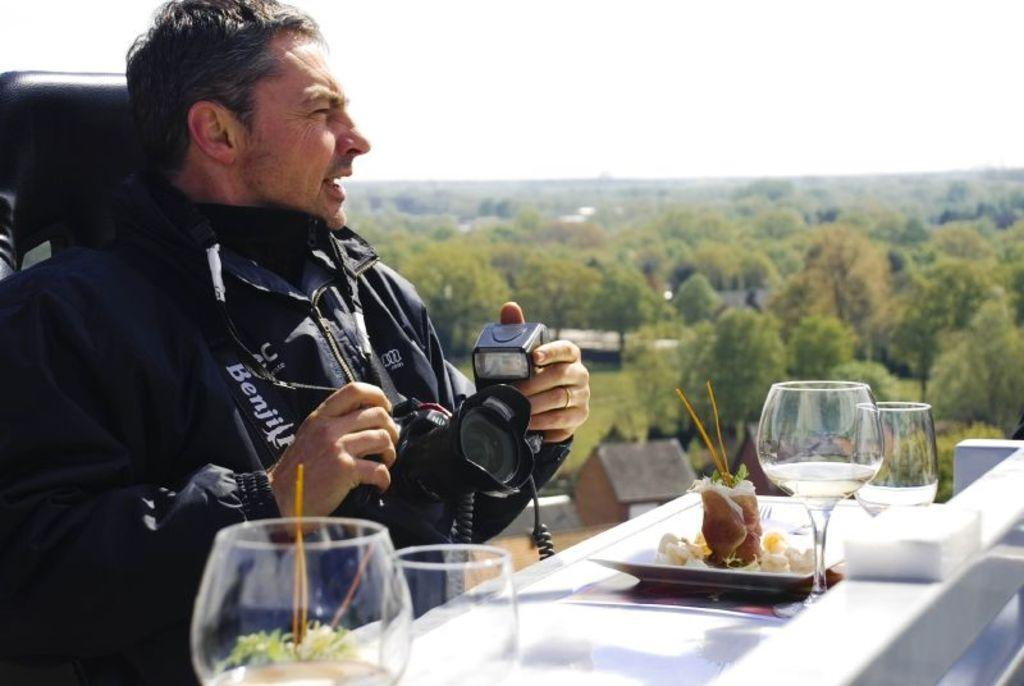What can be seen in the background of the image? There is a sky and trees in the image. What is the man in the image doing? The man is sitting on a chair in the image. What is the man holding in his hand? The man is holding a camera in his hand. What is on the table in the image? There are glasses on the table in the image. What type of club is the man using to take a picture in the image? There is no club present in the image; the man is holding a camera. Can you see a pear on the table in the image? There is no pear present on the table in the image; there are only glasses. 